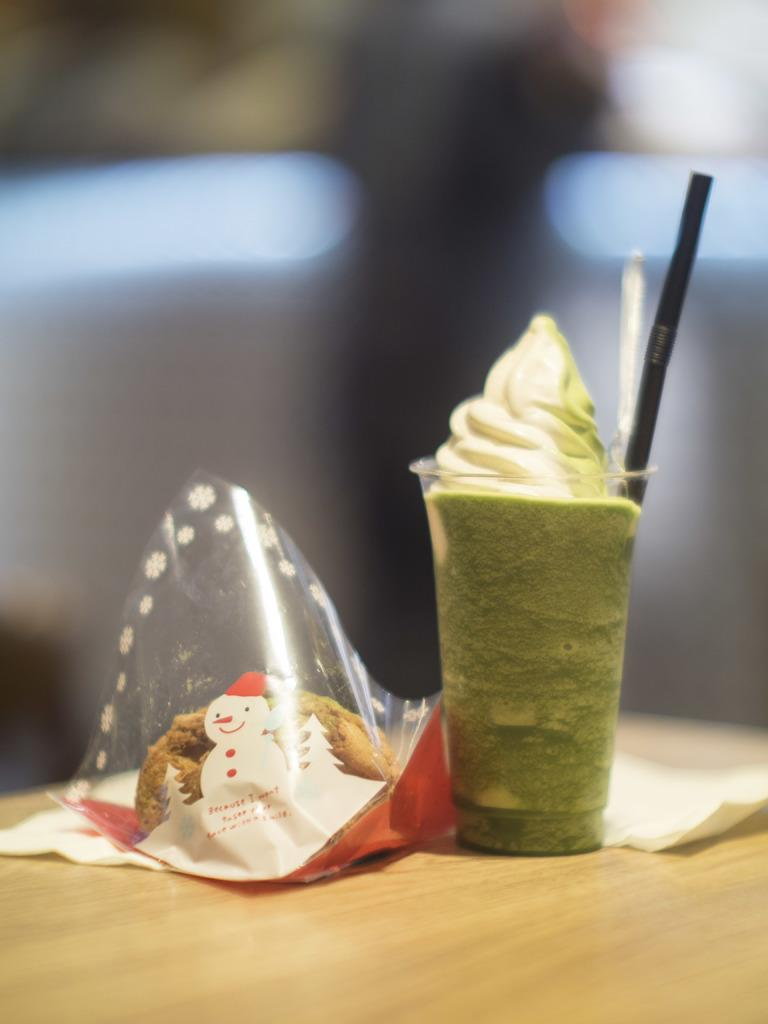What type of dessert is in the image? There is an ice cream in the image. How is the ice cream contained in the image? The ice cream is in a glass. What else can be seen in the image besides the ice cream? There are food items in a plastic cover in the image. What type of behavior does the ice cream exhibit in the image? The ice cream does not exhibit any behavior in the image, as it is an inanimate object. 